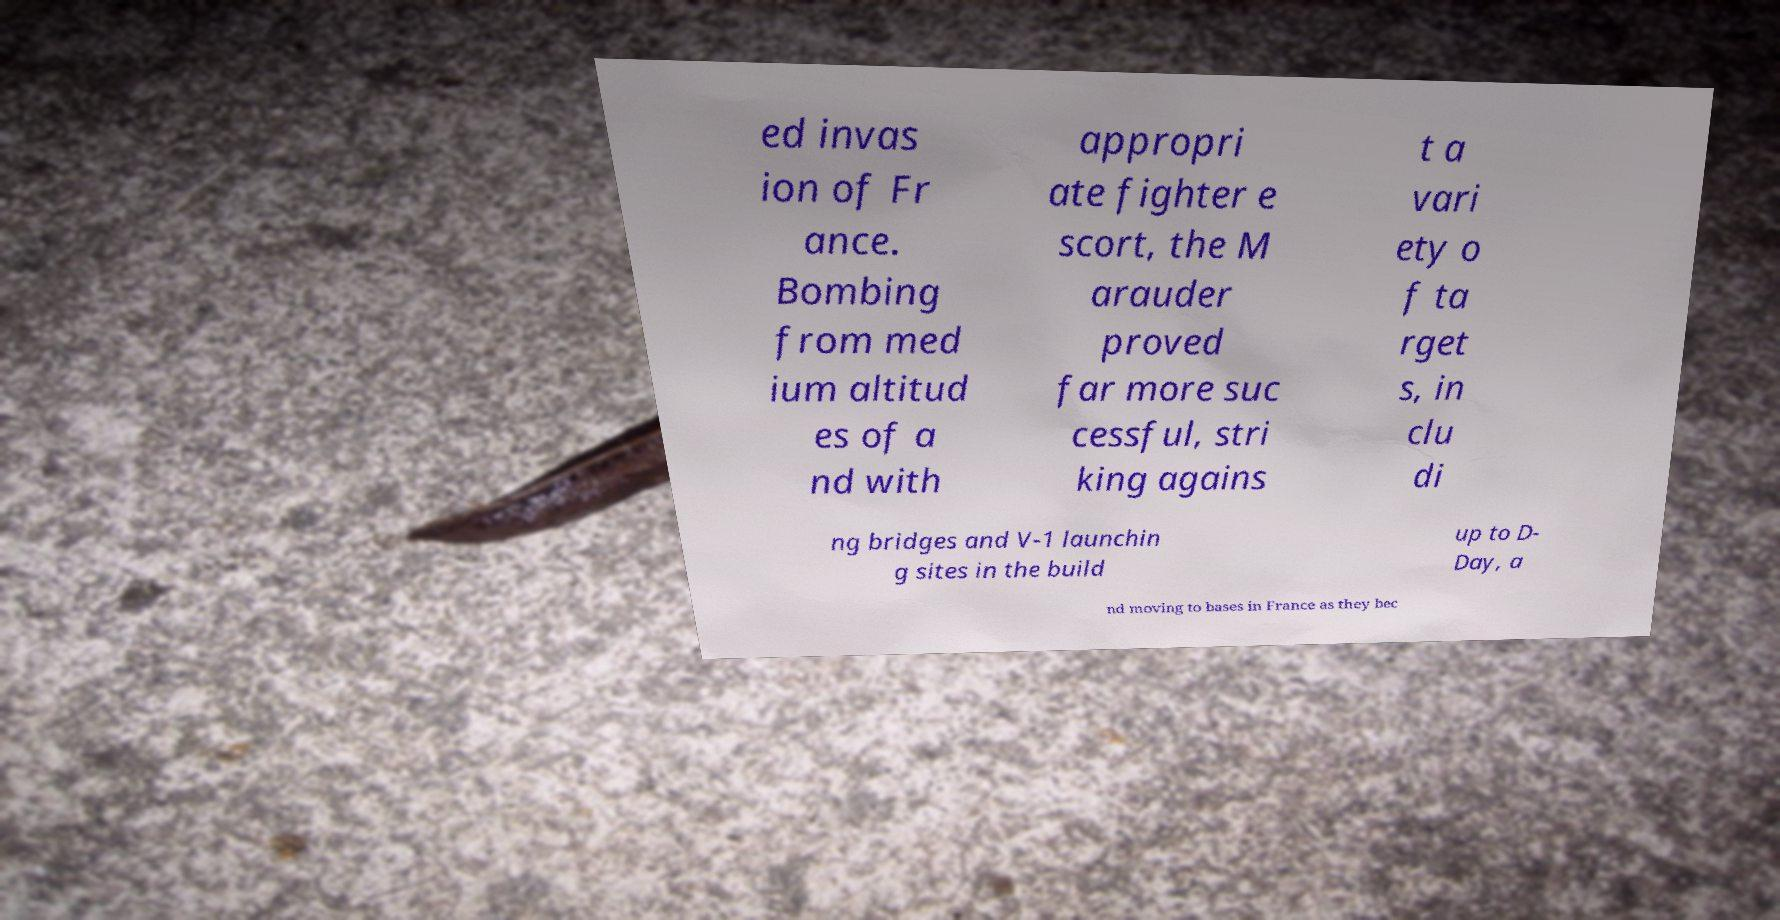Please read and relay the text visible in this image. What does it say? ed invas ion of Fr ance. Bombing from med ium altitud es of a nd with appropri ate fighter e scort, the M arauder proved far more suc cessful, stri king agains t a vari ety o f ta rget s, in clu di ng bridges and V-1 launchin g sites in the build up to D- Day, a nd moving to bases in France as they bec 